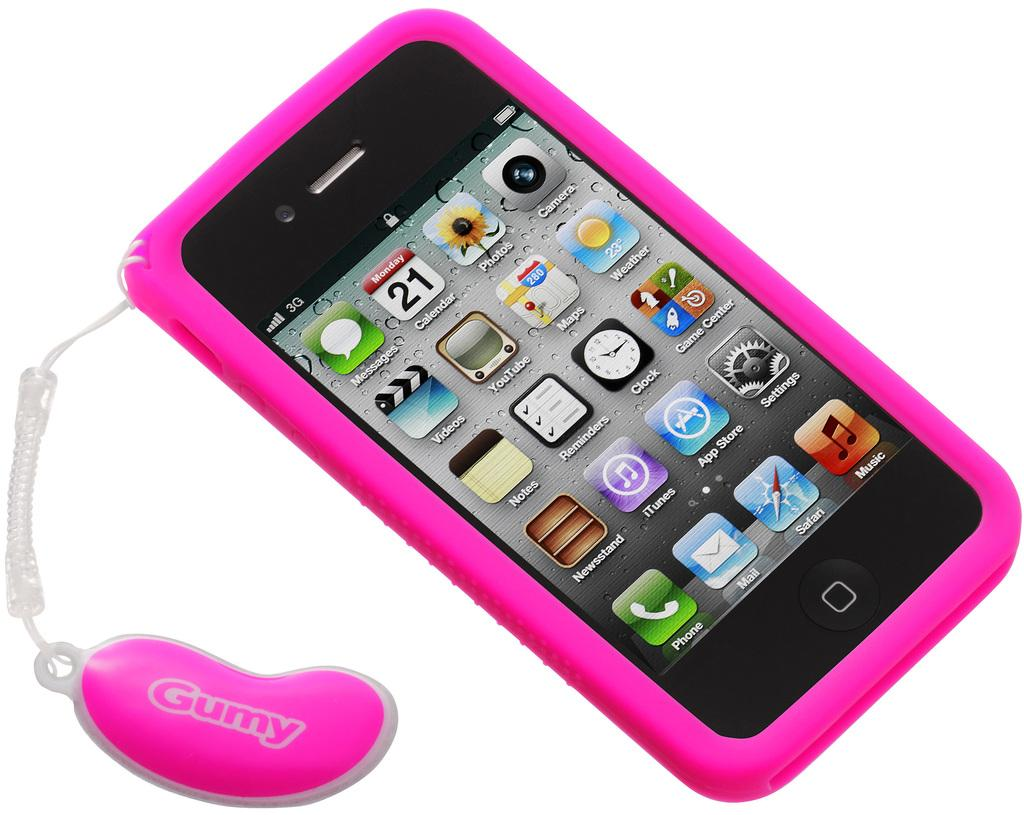<image>
Offer a succinct explanation of the picture presented. A pink smart phone with the number 21 visible on it. 